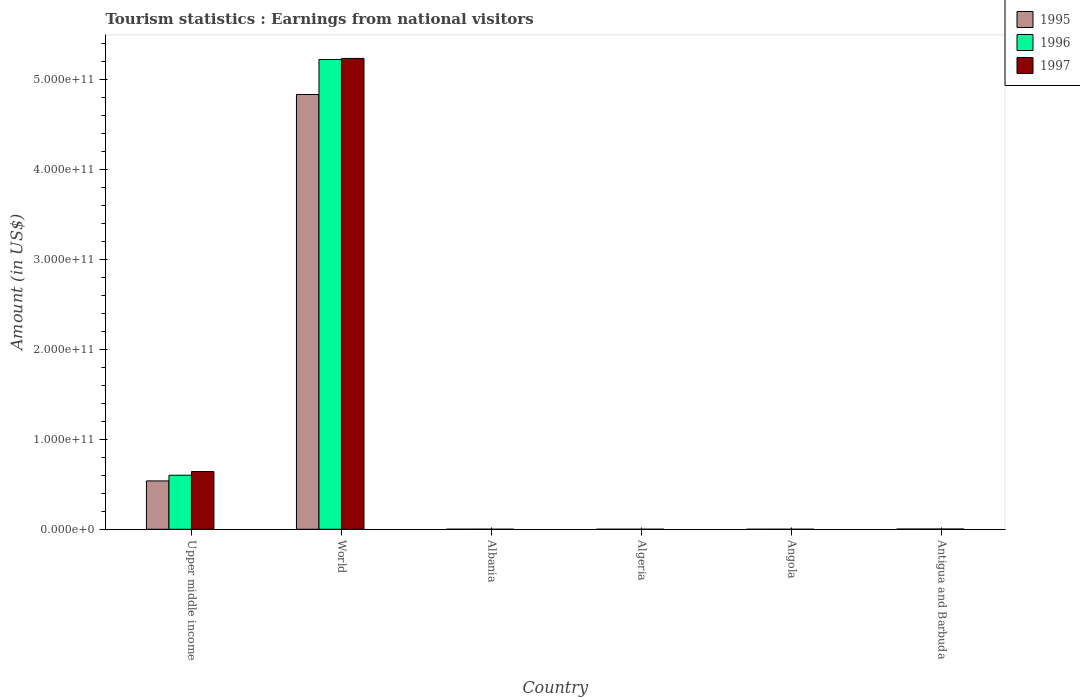How many groups of bars are there?
Your answer should be compact. 6. Are the number of bars per tick equal to the number of legend labels?
Your answer should be compact. Yes. How many bars are there on the 3rd tick from the left?
Offer a terse response. 3. How many bars are there on the 1st tick from the right?
Offer a very short reply. 3. What is the label of the 1st group of bars from the left?
Your response must be concise. Upper middle income. What is the earnings from national visitors in 1996 in Algeria?
Offer a terse response. 4.50e+07. Across all countries, what is the maximum earnings from national visitors in 1995?
Make the answer very short. 4.84e+11. Across all countries, what is the minimum earnings from national visitors in 1996?
Your answer should be very brief. 3.80e+07. In which country was the earnings from national visitors in 1996 maximum?
Ensure brevity in your answer.  World. In which country was the earnings from national visitors in 1995 minimum?
Provide a short and direct response. Angola. What is the total earnings from national visitors in 1996 in the graph?
Offer a very short reply. 5.83e+11. What is the difference between the earnings from national visitors in 1996 in Antigua and Barbuda and that in Upper middle income?
Your answer should be very brief. -5.99e+1. What is the difference between the earnings from national visitors in 1997 in Albania and the earnings from national visitors in 1995 in Algeria?
Provide a succinct answer. 1.60e+06. What is the average earnings from national visitors in 1997 per country?
Keep it short and to the point. 9.81e+1. What is the difference between the earnings from national visitors of/in 1996 and earnings from national visitors of/in 1997 in Angola?
Provide a succinct answer. 1.40e+07. What is the ratio of the earnings from national visitors in 1996 in Algeria to that in World?
Keep it short and to the point. 8.609439191956067e-5. Is the earnings from national visitors in 1996 in Algeria less than that in Upper middle income?
Give a very brief answer. Yes. What is the difference between the highest and the second highest earnings from national visitors in 1995?
Keep it short and to the point. 4.30e+11. What is the difference between the highest and the lowest earnings from national visitors in 1997?
Your answer should be compact. 5.24e+11. In how many countries, is the earnings from national visitors in 1996 greater than the average earnings from national visitors in 1996 taken over all countries?
Provide a short and direct response. 1. What does the 3rd bar from the right in Antigua and Barbuda represents?
Your answer should be very brief. 1995. Is it the case that in every country, the sum of the earnings from national visitors in 1997 and earnings from national visitors in 1995 is greater than the earnings from national visitors in 1996?
Offer a very short reply. Yes. How many bars are there?
Your answer should be very brief. 18. What is the difference between two consecutive major ticks on the Y-axis?
Give a very brief answer. 1.00e+11. Are the values on the major ticks of Y-axis written in scientific E-notation?
Offer a very short reply. Yes. Where does the legend appear in the graph?
Give a very brief answer. Top right. How many legend labels are there?
Your response must be concise. 3. How are the legend labels stacked?
Provide a succinct answer. Vertical. What is the title of the graph?
Ensure brevity in your answer.  Tourism statistics : Earnings from national visitors. What is the Amount (in US$) in 1995 in Upper middle income?
Your answer should be very brief. 5.38e+1. What is the Amount (in US$) of 1996 in Upper middle income?
Give a very brief answer. 6.01e+1. What is the Amount (in US$) of 1997 in Upper middle income?
Keep it short and to the point. 6.43e+1. What is the Amount (in US$) of 1995 in World?
Offer a terse response. 4.84e+11. What is the Amount (in US$) in 1996 in World?
Your response must be concise. 5.23e+11. What is the Amount (in US$) in 1997 in World?
Ensure brevity in your answer.  5.24e+11. What is the Amount (in US$) of 1995 in Albania?
Offer a terse response. 7.04e+07. What is the Amount (in US$) of 1996 in Albania?
Offer a terse response. 9.38e+07. What is the Amount (in US$) in 1997 in Albania?
Offer a terse response. 3.36e+07. What is the Amount (in US$) in 1995 in Algeria?
Provide a succinct answer. 3.20e+07. What is the Amount (in US$) of 1996 in Algeria?
Offer a very short reply. 4.50e+07. What is the Amount (in US$) in 1997 in Algeria?
Your answer should be compact. 2.80e+07. What is the Amount (in US$) in 1995 in Angola?
Ensure brevity in your answer.  2.70e+07. What is the Amount (in US$) in 1996 in Angola?
Provide a short and direct response. 3.80e+07. What is the Amount (in US$) in 1997 in Angola?
Ensure brevity in your answer.  2.40e+07. What is the Amount (in US$) in 1995 in Antigua and Barbuda?
Make the answer very short. 2.47e+08. What is the Amount (in US$) of 1996 in Antigua and Barbuda?
Offer a very short reply. 2.58e+08. What is the Amount (in US$) of 1997 in Antigua and Barbuda?
Offer a very short reply. 2.78e+08. Across all countries, what is the maximum Amount (in US$) in 1995?
Provide a short and direct response. 4.84e+11. Across all countries, what is the maximum Amount (in US$) in 1996?
Offer a terse response. 5.23e+11. Across all countries, what is the maximum Amount (in US$) of 1997?
Make the answer very short. 5.24e+11. Across all countries, what is the minimum Amount (in US$) in 1995?
Offer a terse response. 2.70e+07. Across all countries, what is the minimum Amount (in US$) in 1996?
Give a very brief answer. 3.80e+07. Across all countries, what is the minimum Amount (in US$) in 1997?
Provide a short and direct response. 2.40e+07. What is the total Amount (in US$) in 1995 in the graph?
Provide a short and direct response. 5.38e+11. What is the total Amount (in US$) in 1996 in the graph?
Your response must be concise. 5.83e+11. What is the total Amount (in US$) in 1997 in the graph?
Provide a short and direct response. 5.88e+11. What is the difference between the Amount (in US$) of 1995 in Upper middle income and that in World?
Your response must be concise. -4.30e+11. What is the difference between the Amount (in US$) in 1996 in Upper middle income and that in World?
Ensure brevity in your answer.  -4.63e+11. What is the difference between the Amount (in US$) in 1997 in Upper middle income and that in World?
Keep it short and to the point. -4.60e+11. What is the difference between the Amount (in US$) in 1995 in Upper middle income and that in Albania?
Offer a terse response. 5.37e+1. What is the difference between the Amount (in US$) in 1996 in Upper middle income and that in Albania?
Your response must be concise. 6.00e+1. What is the difference between the Amount (in US$) in 1997 in Upper middle income and that in Albania?
Provide a short and direct response. 6.42e+1. What is the difference between the Amount (in US$) of 1995 in Upper middle income and that in Algeria?
Keep it short and to the point. 5.38e+1. What is the difference between the Amount (in US$) in 1996 in Upper middle income and that in Algeria?
Your response must be concise. 6.01e+1. What is the difference between the Amount (in US$) of 1997 in Upper middle income and that in Algeria?
Provide a short and direct response. 6.42e+1. What is the difference between the Amount (in US$) of 1995 in Upper middle income and that in Angola?
Your answer should be very brief. 5.38e+1. What is the difference between the Amount (in US$) in 1996 in Upper middle income and that in Angola?
Your response must be concise. 6.01e+1. What is the difference between the Amount (in US$) in 1997 in Upper middle income and that in Angola?
Your answer should be very brief. 6.42e+1. What is the difference between the Amount (in US$) in 1995 in Upper middle income and that in Antigua and Barbuda?
Make the answer very short. 5.35e+1. What is the difference between the Amount (in US$) in 1996 in Upper middle income and that in Antigua and Barbuda?
Give a very brief answer. 5.99e+1. What is the difference between the Amount (in US$) in 1997 in Upper middle income and that in Antigua and Barbuda?
Provide a succinct answer. 6.40e+1. What is the difference between the Amount (in US$) in 1995 in World and that in Albania?
Give a very brief answer. 4.84e+11. What is the difference between the Amount (in US$) in 1996 in World and that in Albania?
Ensure brevity in your answer.  5.23e+11. What is the difference between the Amount (in US$) in 1997 in World and that in Albania?
Offer a terse response. 5.24e+11. What is the difference between the Amount (in US$) in 1995 in World and that in Algeria?
Make the answer very short. 4.84e+11. What is the difference between the Amount (in US$) in 1996 in World and that in Algeria?
Provide a short and direct response. 5.23e+11. What is the difference between the Amount (in US$) of 1997 in World and that in Algeria?
Keep it short and to the point. 5.24e+11. What is the difference between the Amount (in US$) in 1995 in World and that in Angola?
Keep it short and to the point. 4.84e+11. What is the difference between the Amount (in US$) of 1996 in World and that in Angola?
Your answer should be very brief. 5.23e+11. What is the difference between the Amount (in US$) in 1997 in World and that in Angola?
Offer a terse response. 5.24e+11. What is the difference between the Amount (in US$) of 1995 in World and that in Antigua and Barbuda?
Your response must be concise. 4.83e+11. What is the difference between the Amount (in US$) of 1996 in World and that in Antigua and Barbuda?
Ensure brevity in your answer.  5.22e+11. What is the difference between the Amount (in US$) of 1997 in World and that in Antigua and Barbuda?
Provide a short and direct response. 5.24e+11. What is the difference between the Amount (in US$) in 1995 in Albania and that in Algeria?
Keep it short and to the point. 3.84e+07. What is the difference between the Amount (in US$) of 1996 in Albania and that in Algeria?
Offer a very short reply. 4.88e+07. What is the difference between the Amount (in US$) in 1997 in Albania and that in Algeria?
Provide a succinct answer. 5.60e+06. What is the difference between the Amount (in US$) of 1995 in Albania and that in Angola?
Give a very brief answer. 4.34e+07. What is the difference between the Amount (in US$) of 1996 in Albania and that in Angola?
Keep it short and to the point. 5.58e+07. What is the difference between the Amount (in US$) of 1997 in Albania and that in Angola?
Make the answer very short. 9.60e+06. What is the difference between the Amount (in US$) in 1995 in Albania and that in Antigua and Barbuda?
Offer a terse response. -1.77e+08. What is the difference between the Amount (in US$) of 1996 in Albania and that in Antigua and Barbuda?
Give a very brief answer. -1.64e+08. What is the difference between the Amount (in US$) of 1997 in Albania and that in Antigua and Barbuda?
Provide a succinct answer. -2.44e+08. What is the difference between the Amount (in US$) of 1995 in Algeria and that in Antigua and Barbuda?
Your response must be concise. -2.15e+08. What is the difference between the Amount (in US$) in 1996 in Algeria and that in Antigua and Barbuda?
Your answer should be very brief. -2.13e+08. What is the difference between the Amount (in US$) in 1997 in Algeria and that in Antigua and Barbuda?
Your response must be concise. -2.50e+08. What is the difference between the Amount (in US$) of 1995 in Angola and that in Antigua and Barbuda?
Keep it short and to the point. -2.20e+08. What is the difference between the Amount (in US$) of 1996 in Angola and that in Antigua and Barbuda?
Provide a short and direct response. -2.20e+08. What is the difference between the Amount (in US$) of 1997 in Angola and that in Antigua and Barbuda?
Your answer should be compact. -2.54e+08. What is the difference between the Amount (in US$) of 1995 in Upper middle income and the Amount (in US$) of 1996 in World?
Your answer should be compact. -4.69e+11. What is the difference between the Amount (in US$) of 1995 in Upper middle income and the Amount (in US$) of 1997 in World?
Your answer should be very brief. -4.70e+11. What is the difference between the Amount (in US$) of 1996 in Upper middle income and the Amount (in US$) of 1997 in World?
Ensure brevity in your answer.  -4.64e+11. What is the difference between the Amount (in US$) in 1995 in Upper middle income and the Amount (in US$) in 1996 in Albania?
Your answer should be compact. 5.37e+1. What is the difference between the Amount (in US$) of 1995 in Upper middle income and the Amount (in US$) of 1997 in Albania?
Ensure brevity in your answer.  5.38e+1. What is the difference between the Amount (in US$) in 1996 in Upper middle income and the Amount (in US$) in 1997 in Albania?
Provide a succinct answer. 6.01e+1. What is the difference between the Amount (in US$) in 1995 in Upper middle income and the Amount (in US$) in 1996 in Algeria?
Provide a short and direct response. 5.38e+1. What is the difference between the Amount (in US$) of 1995 in Upper middle income and the Amount (in US$) of 1997 in Algeria?
Make the answer very short. 5.38e+1. What is the difference between the Amount (in US$) in 1996 in Upper middle income and the Amount (in US$) in 1997 in Algeria?
Make the answer very short. 6.01e+1. What is the difference between the Amount (in US$) of 1995 in Upper middle income and the Amount (in US$) of 1996 in Angola?
Provide a succinct answer. 5.38e+1. What is the difference between the Amount (in US$) of 1995 in Upper middle income and the Amount (in US$) of 1997 in Angola?
Ensure brevity in your answer.  5.38e+1. What is the difference between the Amount (in US$) of 1996 in Upper middle income and the Amount (in US$) of 1997 in Angola?
Offer a very short reply. 6.01e+1. What is the difference between the Amount (in US$) in 1995 in Upper middle income and the Amount (in US$) in 1996 in Antigua and Barbuda?
Provide a short and direct response. 5.35e+1. What is the difference between the Amount (in US$) of 1995 in Upper middle income and the Amount (in US$) of 1997 in Antigua and Barbuda?
Ensure brevity in your answer.  5.35e+1. What is the difference between the Amount (in US$) in 1996 in Upper middle income and the Amount (in US$) in 1997 in Antigua and Barbuda?
Provide a short and direct response. 5.98e+1. What is the difference between the Amount (in US$) in 1995 in World and the Amount (in US$) in 1996 in Albania?
Ensure brevity in your answer.  4.84e+11. What is the difference between the Amount (in US$) of 1995 in World and the Amount (in US$) of 1997 in Albania?
Give a very brief answer. 4.84e+11. What is the difference between the Amount (in US$) in 1996 in World and the Amount (in US$) in 1997 in Albania?
Your response must be concise. 5.23e+11. What is the difference between the Amount (in US$) of 1995 in World and the Amount (in US$) of 1996 in Algeria?
Offer a terse response. 4.84e+11. What is the difference between the Amount (in US$) of 1995 in World and the Amount (in US$) of 1997 in Algeria?
Ensure brevity in your answer.  4.84e+11. What is the difference between the Amount (in US$) in 1996 in World and the Amount (in US$) in 1997 in Algeria?
Keep it short and to the point. 5.23e+11. What is the difference between the Amount (in US$) of 1995 in World and the Amount (in US$) of 1996 in Angola?
Ensure brevity in your answer.  4.84e+11. What is the difference between the Amount (in US$) of 1995 in World and the Amount (in US$) of 1997 in Angola?
Ensure brevity in your answer.  4.84e+11. What is the difference between the Amount (in US$) in 1996 in World and the Amount (in US$) in 1997 in Angola?
Your answer should be compact. 5.23e+11. What is the difference between the Amount (in US$) of 1995 in World and the Amount (in US$) of 1996 in Antigua and Barbuda?
Ensure brevity in your answer.  4.83e+11. What is the difference between the Amount (in US$) of 1995 in World and the Amount (in US$) of 1997 in Antigua and Barbuda?
Provide a short and direct response. 4.83e+11. What is the difference between the Amount (in US$) in 1996 in World and the Amount (in US$) in 1997 in Antigua and Barbuda?
Provide a succinct answer. 5.22e+11. What is the difference between the Amount (in US$) of 1995 in Albania and the Amount (in US$) of 1996 in Algeria?
Provide a succinct answer. 2.54e+07. What is the difference between the Amount (in US$) of 1995 in Albania and the Amount (in US$) of 1997 in Algeria?
Give a very brief answer. 4.24e+07. What is the difference between the Amount (in US$) of 1996 in Albania and the Amount (in US$) of 1997 in Algeria?
Your response must be concise. 6.58e+07. What is the difference between the Amount (in US$) in 1995 in Albania and the Amount (in US$) in 1996 in Angola?
Ensure brevity in your answer.  3.24e+07. What is the difference between the Amount (in US$) of 1995 in Albania and the Amount (in US$) of 1997 in Angola?
Give a very brief answer. 4.64e+07. What is the difference between the Amount (in US$) of 1996 in Albania and the Amount (in US$) of 1997 in Angola?
Make the answer very short. 6.98e+07. What is the difference between the Amount (in US$) in 1995 in Albania and the Amount (in US$) in 1996 in Antigua and Barbuda?
Keep it short and to the point. -1.88e+08. What is the difference between the Amount (in US$) of 1995 in Albania and the Amount (in US$) of 1997 in Antigua and Barbuda?
Your response must be concise. -2.08e+08. What is the difference between the Amount (in US$) of 1996 in Albania and the Amount (in US$) of 1997 in Antigua and Barbuda?
Your answer should be very brief. -1.84e+08. What is the difference between the Amount (in US$) of 1995 in Algeria and the Amount (in US$) of 1996 in Angola?
Keep it short and to the point. -6.00e+06. What is the difference between the Amount (in US$) in 1995 in Algeria and the Amount (in US$) in 1997 in Angola?
Your answer should be compact. 8.00e+06. What is the difference between the Amount (in US$) in 1996 in Algeria and the Amount (in US$) in 1997 in Angola?
Give a very brief answer. 2.10e+07. What is the difference between the Amount (in US$) of 1995 in Algeria and the Amount (in US$) of 1996 in Antigua and Barbuda?
Make the answer very short. -2.26e+08. What is the difference between the Amount (in US$) in 1995 in Algeria and the Amount (in US$) in 1997 in Antigua and Barbuda?
Make the answer very short. -2.46e+08. What is the difference between the Amount (in US$) of 1996 in Algeria and the Amount (in US$) of 1997 in Antigua and Barbuda?
Your response must be concise. -2.33e+08. What is the difference between the Amount (in US$) in 1995 in Angola and the Amount (in US$) in 1996 in Antigua and Barbuda?
Make the answer very short. -2.31e+08. What is the difference between the Amount (in US$) of 1995 in Angola and the Amount (in US$) of 1997 in Antigua and Barbuda?
Your response must be concise. -2.51e+08. What is the difference between the Amount (in US$) in 1996 in Angola and the Amount (in US$) in 1997 in Antigua and Barbuda?
Your answer should be very brief. -2.40e+08. What is the average Amount (in US$) in 1995 per country?
Your response must be concise. 8.96e+1. What is the average Amount (in US$) of 1996 per country?
Offer a terse response. 9.72e+1. What is the average Amount (in US$) in 1997 per country?
Offer a terse response. 9.81e+1. What is the difference between the Amount (in US$) in 1995 and Amount (in US$) in 1996 in Upper middle income?
Keep it short and to the point. -6.33e+09. What is the difference between the Amount (in US$) in 1995 and Amount (in US$) in 1997 in Upper middle income?
Provide a succinct answer. -1.05e+1. What is the difference between the Amount (in US$) in 1996 and Amount (in US$) in 1997 in Upper middle income?
Your answer should be compact. -4.15e+09. What is the difference between the Amount (in US$) of 1995 and Amount (in US$) of 1996 in World?
Ensure brevity in your answer.  -3.90e+1. What is the difference between the Amount (in US$) of 1995 and Amount (in US$) of 1997 in World?
Your response must be concise. -4.01e+1. What is the difference between the Amount (in US$) in 1996 and Amount (in US$) in 1997 in World?
Ensure brevity in your answer.  -1.17e+09. What is the difference between the Amount (in US$) of 1995 and Amount (in US$) of 1996 in Albania?
Offer a terse response. -2.34e+07. What is the difference between the Amount (in US$) in 1995 and Amount (in US$) in 1997 in Albania?
Your answer should be compact. 3.68e+07. What is the difference between the Amount (in US$) in 1996 and Amount (in US$) in 1997 in Albania?
Provide a short and direct response. 6.02e+07. What is the difference between the Amount (in US$) in 1995 and Amount (in US$) in 1996 in Algeria?
Provide a succinct answer. -1.30e+07. What is the difference between the Amount (in US$) of 1996 and Amount (in US$) of 1997 in Algeria?
Provide a short and direct response. 1.70e+07. What is the difference between the Amount (in US$) of 1995 and Amount (in US$) of 1996 in Angola?
Provide a short and direct response. -1.10e+07. What is the difference between the Amount (in US$) in 1996 and Amount (in US$) in 1997 in Angola?
Your answer should be very brief. 1.40e+07. What is the difference between the Amount (in US$) of 1995 and Amount (in US$) of 1996 in Antigua and Barbuda?
Your answer should be compact. -1.10e+07. What is the difference between the Amount (in US$) in 1995 and Amount (in US$) in 1997 in Antigua and Barbuda?
Make the answer very short. -3.10e+07. What is the difference between the Amount (in US$) in 1996 and Amount (in US$) in 1997 in Antigua and Barbuda?
Make the answer very short. -2.00e+07. What is the ratio of the Amount (in US$) of 1995 in Upper middle income to that in World?
Your answer should be compact. 0.11. What is the ratio of the Amount (in US$) of 1996 in Upper middle income to that in World?
Provide a succinct answer. 0.12. What is the ratio of the Amount (in US$) of 1997 in Upper middle income to that in World?
Your answer should be very brief. 0.12. What is the ratio of the Amount (in US$) in 1995 in Upper middle income to that in Albania?
Provide a succinct answer. 764.16. What is the ratio of the Amount (in US$) of 1996 in Upper middle income to that in Albania?
Provide a succinct answer. 641.02. What is the ratio of the Amount (in US$) of 1997 in Upper middle income to that in Albania?
Ensure brevity in your answer.  1912.87. What is the ratio of the Amount (in US$) in 1995 in Upper middle income to that in Algeria?
Make the answer very short. 1681.15. What is the ratio of the Amount (in US$) of 1996 in Upper middle income to that in Algeria?
Make the answer very short. 1336.17. What is the ratio of the Amount (in US$) of 1997 in Upper middle income to that in Algeria?
Keep it short and to the point. 2295.45. What is the ratio of the Amount (in US$) in 1995 in Upper middle income to that in Angola?
Keep it short and to the point. 1992.48. What is the ratio of the Amount (in US$) of 1996 in Upper middle income to that in Angola?
Your answer should be very brief. 1582.3. What is the ratio of the Amount (in US$) in 1997 in Upper middle income to that in Angola?
Give a very brief answer. 2678.02. What is the ratio of the Amount (in US$) in 1995 in Upper middle income to that in Antigua and Barbuda?
Ensure brevity in your answer.  217.8. What is the ratio of the Amount (in US$) in 1996 in Upper middle income to that in Antigua and Barbuda?
Provide a succinct answer. 233.05. What is the ratio of the Amount (in US$) in 1997 in Upper middle income to that in Antigua and Barbuda?
Your answer should be very brief. 231.2. What is the ratio of the Amount (in US$) in 1995 in World to that in Albania?
Provide a short and direct response. 6871.01. What is the ratio of the Amount (in US$) of 1996 in World to that in Albania?
Keep it short and to the point. 5572.3. What is the ratio of the Amount (in US$) in 1997 in World to that in Albania?
Offer a terse response. 1.56e+04. What is the ratio of the Amount (in US$) of 1995 in World to that in Algeria?
Your answer should be compact. 1.51e+04. What is the ratio of the Amount (in US$) in 1996 in World to that in Algeria?
Provide a succinct answer. 1.16e+04. What is the ratio of the Amount (in US$) in 1997 in World to that in Algeria?
Make the answer very short. 1.87e+04. What is the ratio of the Amount (in US$) in 1995 in World to that in Angola?
Your answer should be very brief. 1.79e+04. What is the ratio of the Amount (in US$) of 1996 in World to that in Angola?
Make the answer very short. 1.38e+04. What is the ratio of the Amount (in US$) of 1997 in World to that in Angola?
Provide a short and direct response. 2.18e+04. What is the ratio of the Amount (in US$) of 1995 in World to that in Antigua and Barbuda?
Provide a succinct answer. 1958.38. What is the ratio of the Amount (in US$) in 1996 in World to that in Antigua and Barbuda?
Ensure brevity in your answer.  2025.9. What is the ratio of the Amount (in US$) in 1997 in World to that in Antigua and Barbuda?
Offer a terse response. 1884.35. What is the ratio of the Amount (in US$) in 1995 in Albania to that in Algeria?
Keep it short and to the point. 2.2. What is the ratio of the Amount (in US$) of 1996 in Albania to that in Algeria?
Ensure brevity in your answer.  2.08. What is the ratio of the Amount (in US$) of 1995 in Albania to that in Angola?
Your answer should be compact. 2.61. What is the ratio of the Amount (in US$) of 1996 in Albania to that in Angola?
Keep it short and to the point. 2.47. What is the ratio of the Amount (in US$) of 1997 in Albania to that in Angola?
Give a very brief answer. 1.4. What is the ratio of the Amount (in US$) in 1995 in Albania to that in Antigua and Barbuda?
Offer a very short reply. 0.28. What is the ratio of the Amount (in US$) in 1996 in Albania to that in Antigua and Barbuda?
Your answer should be compact. 0.36. What is the ratio of the Amount (in US$) in 1997 in Albania to that in Antigua and Barbuda?
Your answer should be very brief. 0.12. What is the ratio of the Amount (in US$) of 1995 in Algeria to that in Angola?
Provide a succinct answer. 1.19. What is the ratio of the Amount (in US$) of 1996 in Algeria to that in Angola?
Give a very brief answer. 1.18. What is the ratio of the Amount (in US$) in 1997 in Algeria to that in Angola?
Your response must be concise. 1.17. What is the ratio of the Amount (in US$) in 1995 in Algeria to that in Antigua and Barbuda?
Your answer should be compact. 0.13. What is the ratio of the Amount (in US$) of 1996 in Algeria to that in Antigua and Barbuda?
Make the answer very short. 0.17. What is the ratio of the Amount (in US$) in 1997 in Algeria to that in Antigua and Barbuda?
Provide a succinct answer. 0.1. What is the ratio of the Amount (in US$) of 1995 in Angola to that in Antigua and Barbuda?
Your answer should be compact. 0.11. What is the ratio of the Amount (in US$) of 1996 in Angola to that in Antigua and Barbuda?
Your answer should be compact. 0.15. What is the ratio of the Amount (in US$) of 1997 in Angola to that in Antigua and Barbuda?
Make the answer very short. 0.09. What is the difference between the highest and the second highest Amount (in US$) of 1995?
Ensure brevity in your answer.  4.30e+11. What is the difference between the highest and the second highest Amount (in US$) of 1996?
Make the answer very short. 4.63e+11. What is the difference between the highest and the second highest Amount (in US$) in 1997?
Offer a very short reply. 4.60e+11. What is the difference between the highest and the lowest Amount (in US$) of 1995?
Offer a very short reply. 4.84e+11. What is the difference between the highest and the lowest Amount (in US$) in 1996?
Keep it short and to the point. 5.23e+11. What is the difference between the highest and the lowest Amount (in US$) in 1997?
Make the answer very short. 5.24e+11. 